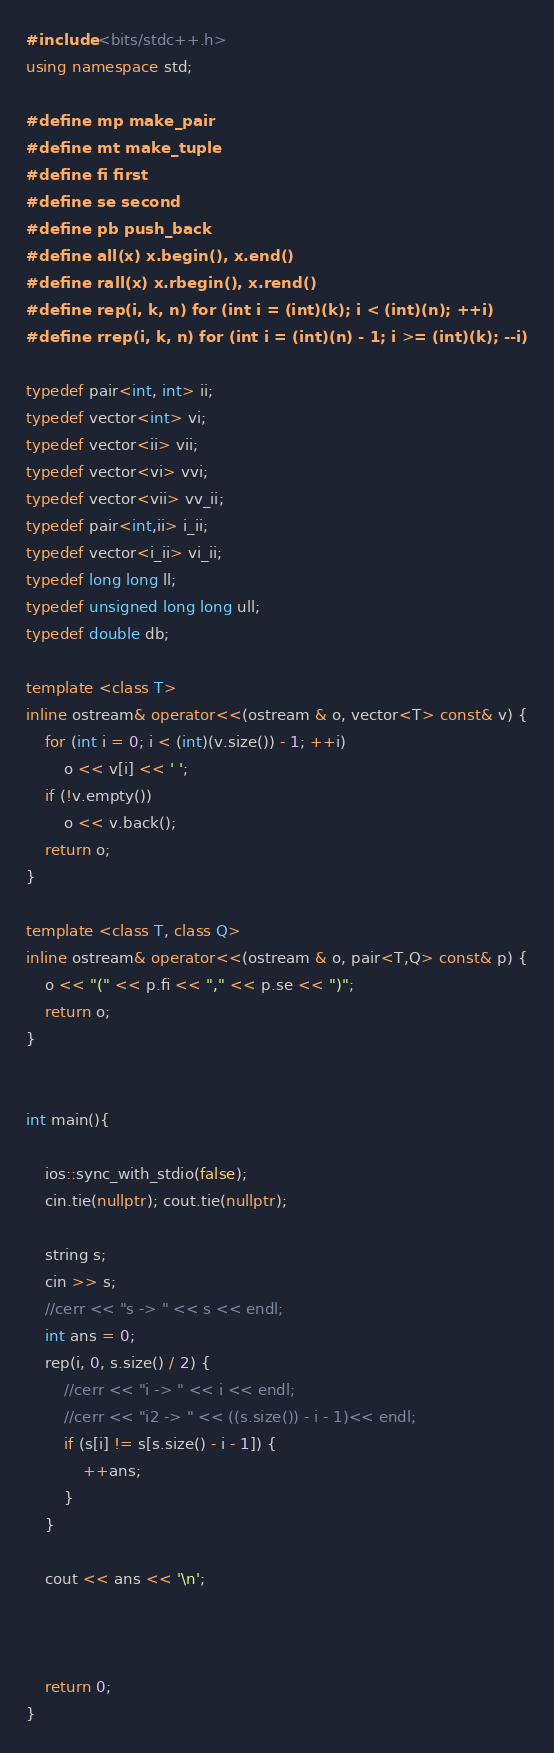<code> <loc_0><loc_0><loc_500><loc_500><_C++_>#include <bits/stdc++.h>
using namespace std;

#define mp make_pair
#define mt make_tuple
#define fi first
#define se second
#define pb push_back
#define all(x) x.begin(), x.end()
#define rall(x) x.rbegin(), x.rend()
#define rep(i, k, n) for (int i = (int)(k); i < (int)(n); ++i)
#define rrep(i, k, n) for (int i = (int)(n) - 1; i >= (int)(k); --i)

typedef pair<int, int> ii;
typedef vector<int> vi;
typedef vector<ii> vii;
typedef vector<vi> vvi;
typedef vector<vii> vv_ii;
typedef pair<int,ii> i_ii;
typedef vector<i_ii> vi_ii;
typedef long long ll;
typedef unsigned long long ull;
typedef double db;

template <class T>
inline ostream& operator<<(ostream & o, vector<T> const& v) {
    for (int i = 0; i < (int)(v.size()) - 1; ++i)
        o << v[i] << ' ';
    if (!v.empty())
        o << v.back();
    return o;
}

template <class T, class Q>
inline ostream& operator<<(ostream & o, pair<T,Q> const& p) {
    o << "(" << p.fi << "," << p.se << ")";
    return o;
}


int main(){

    ios::sync_with_stdio(false);
    cin.tie(nullptr); cout.tie(nullptr);

    string s;
    cin >> s;
    //cerr << "s -> " << s << endl;
    int ans = 0;
    rep(i, 0, s.size() / 2) {
        //cerr << "i -> " << i << endl;
        //cerr << "i2 -> " << ((s.size()) - i - 1)<< endl;
        if (s[i] != s[s.size() - i - 1]) {
            ++ans;
        }
    }

    cout << ans << '\n';
    


    return 0;
}</code> 